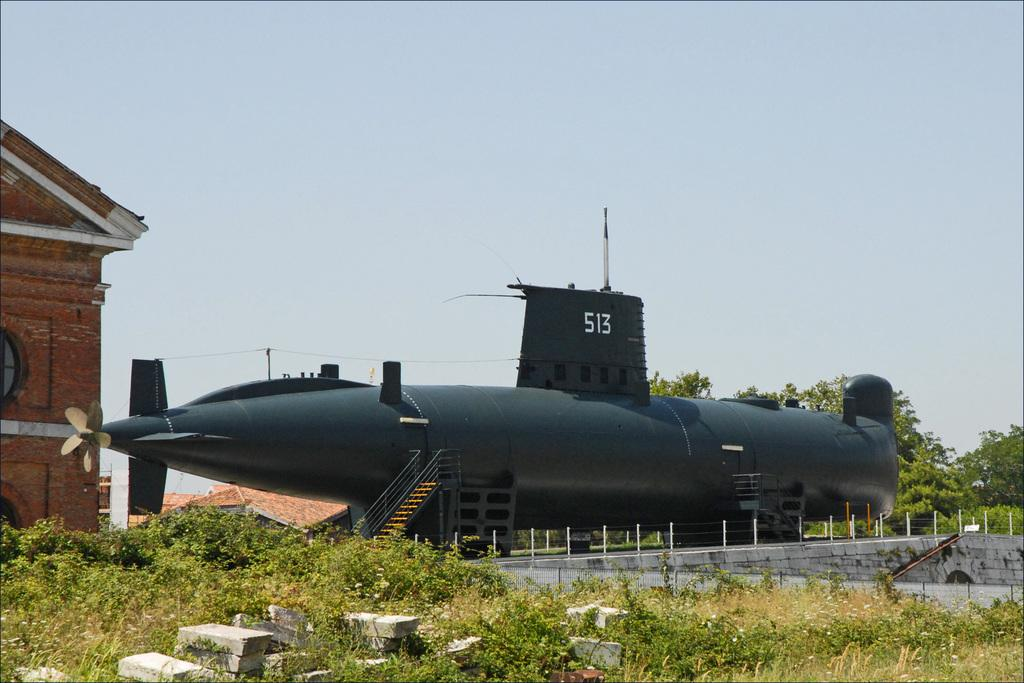What is the main subject of the picture? The main subject of the picture is a submarine. What other structures or objects can be seen in the picture? There is a building, trees, plants, rocks, and a fence visible in the picture. What is visible in the background of the picture? The sky is visible in the background of the picture. How many ladybugs can be seen crawling on the ink in the picture? There are no ladybugs or ink present in the picture; it features a submarine, a building, trees, plants, rocks, a fence, and the sky. 